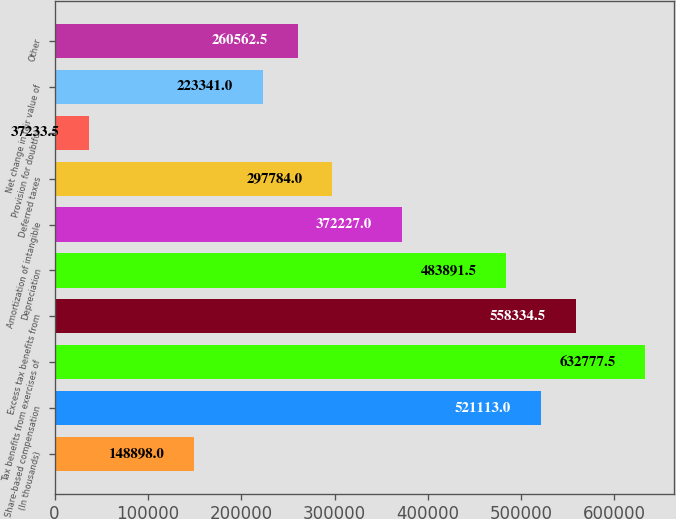Convert chart to OTSL. <chart><loc_0><loc_0><loc_500><loc_500><bar_chart><fcel>(In thousands)<fcel>Share-based compensation<fcel>Tax benefits from exercises of<fcel>Excess tax benefits from<fcel>Depreciation<fcel>Amortization of intangible<fcel>Deferred taxes<fcel>Provision for doubtful<fcel>Net change in fair value of<fcel>Other<nl><fcel>148898<fcel>521113<fcel>632778<fcel>558334<fcel>483892<fcel>372227<fcel>297784<fcel>37233.5<fcel>223341<fcel>260562<nl></chart> 